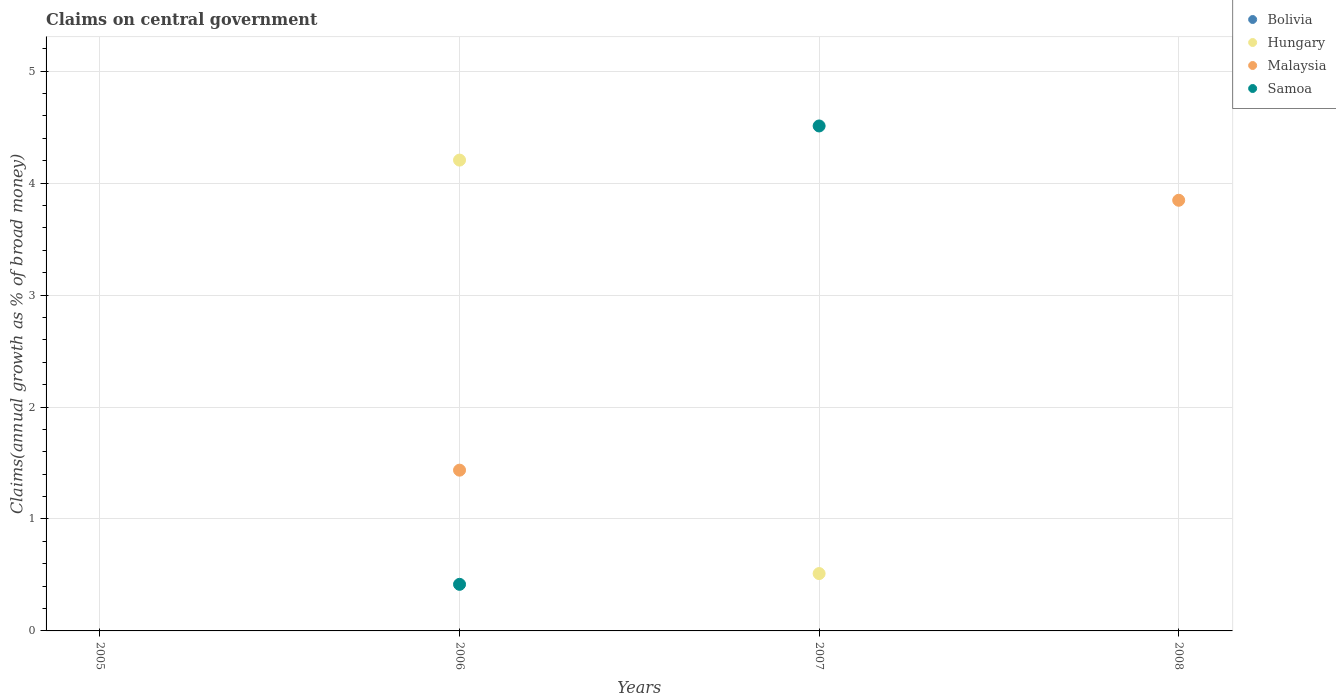What is the percentage of broad money claimed on centeral government in Samoa in 2008?
Your answer should be very brief. 0. Across all years, what is the maximum percentage of broad money claimed on centeral government in Hungary?
Offer a terse response. 4.21. In which year was the percentage of broad money claimed on centeral government in Samoa maximum?
Your response must be concise. 2007. What is the total percentage of broad money claimed on centeral government in Malaysia in the graph?
Give a very brief answer. 5.28. What is the difference between the percentage of broad money claimed on centeral government in Malaysia in 2006 and that in 2008?
Offer a very short reply. -2.41. What is the difference between the percentage of broad money claimed on centeral government in Samoa in 2008 and the percentage of broad money claimed on centeral government in Bolivia in 2007?
Give a very brief answer. 0. What is the average percentage of broad money claimed on centeral government in Malaysia per year?
Make the answer very short. 1.32. In the year 2007, what is the difference between the percentage of broad money claimed on centeral government in Hungary and percentage of broad money claimed on centeral government in Samoa?
Ensure brevity in your answer.  -4. What is the ratio of the percentage of broad money claimed on centeral government in Samoa in 2006 to that in 2007?
Offer a very short reply. 0.09. What is the difference between the highest and the lowest percentage of broad money claimed on centeral government in Hungary?
Your answer should be compact. 4.21. In how many years, is the percentage of broad money claimed on centeral government in Bolivia greater than the average percentage of broad money claimed on centeral government in Bolivia taken over all years?
Your answer should be very brief. 0. Is it the case that in every year, the sum of the percentage of broad money claimed on centeral government in Hungary and percentage of broad money claimed on centeral government in Bolivia  is greater than the sum of percentage of broad money claimed on centeral government in Malaysia and percentage of broad money claimed on centeral government in Samoa?
Your answer should be compact. No. Is the percentage of broad money claimed on centeral government in Samoa strictly less than the percentage of broad money claimed on centeral government in Malaysia over the years?
Provide a succinct answer. No. What is the difference between two consecutive major ticks on the Y-axis?
Ensure brevity in your answer.  1. Where does the legend appear in the graph?
Your answer should be compact. Top right. How many legend labels are there?
Your response must be concise. 4. How are the legend labels stacked?
Your answer should be compact. Vertical. What is the title of the graph?
Keep it short and to the point. Claims on central government. What is the label or title of the X-axis?
Offer a terse response. Years. What is the label or title of the Y-axis?
Offer a terse response. Claims(annual growth as % of broad money). What is the Claims(annual growth as % of broad money) of Bolivia in 2005?
Provide a short and direct response. 0. What is the Claims(annual growth as % of broad money) in Malaysia in 2005?
Provide a short and direct response. 0. What is the Claims(annual growth as % of broad money) in Samoa in 2005?
Your answer should be very brief. 0. What is the Claims(annual growth as % of broad money) in Hungary in 2006?
Give a very brief answer. 4.21. What is the Claims(annual growth as % of broad money) of Malaysia in 2006?
Your answer should be very brief. 1.44. What is the Claims(annual growth as % of broad money) of Samoa in 2006?
Ensure brevity in your answer.  0.42. What is the Claims(annual growth as % of broad money) in Hungary in 2007?
Give a very brief answer. 0.51. What is the Claims(annual growth as % of broad money) in Samoa in 2007?
Give a very brief answer. 4.51. What is the Claims(annual growth as % of broad money) of Bolivia in 2008?
Provide a short and direct response. 0. What is the Claims(annual growth as % of broad money) of Hungary in 2008?
Your answer should be compact. 0. What is the Claims(annual growth as % of broad money) of Malaysia in 2008?
Ensure brevity in your answer.  3.85. Across all years, what is the maximum Claims(annual growth as % of broad money) of Hungary?
Your answer should be compact. 4.21. Across all years, what is the maximum Claims(annual growth as % of broad money) of Malaysia?
Offer a terse response. 3.85. Across all years, what is the maximum Claims(annual growth as % of broad money) in Samoa?
Offer a very short reply. 4.51. Across all years, what is the minimum Claims(annual growth as % of broad money) of Samoa?
Offer a very short reply. 0. What is the total Claims(annual growth as % of broad money) of Hungary in the graph?
Give a very brief answer. 4.72. What is the total Claims(annual growth as % of broad money) of Malaysia in the graph?
Provide a short and direct response. 5.28. What is the total Claims(annual growth as % of broad money) in Samoa in the graph?
Offer a terse response. 4.93. What is the difference between the Claims(annual growth as % of broad money) of Hungary in 2006 and that in 2007?
Your answer should be compact. 3.69. What is the difference between the Claims(annual growth as % of broad money) in Samoa in 2006 and that in 2007?
Give a very brief answer. -4.09. What is the difference between the Claims(annual growth as % of broad money) in Malaysia in 2006 and that in 2008?
Ensure brevity in your answer.  -2.41. What is the difference between the Claims(annual growth as % of broad money) of Hungary in 2006 and the Claims(annual growth as % of broad money) of Samoa in 2007?
Your answer should be compact. -0.3. What is the difference between the Claims(annual growth as % of broad money) in Malaysia in 2006 and the Claims(annual growth as % of broad money) in Samoa in 2007?
Provide a succinct answer. -3.07. What is the difference between the Claims(annual growth as % of broad money) in Hungary in 2006 and the Claims(annual growth as % of broad money) in Malaysia in 2008?
Provide a succinct answer. 0.36. What is the difference between the Claims(annual growth as % of broad money) in Hungary in 2007 and the Claims(annual growth as % of broad money) in Malaysia in 2008?
Keep it short and to the point. -3.33. What is the average Claims(annual growth as % of broad money) of Bolivia per year?
Ensure brevity in your answer.  0. What is the average Claims(annual growth as % of broad money) of Hungary per year?
Your answer should be very brief. 1.18. What is the average Claims(annual growth as % of broad money) of Malaysia per year?
Your response must be concise. 1.32. What is the average Claims(annual growth as % of broad money) of Samoa per year?
Give a very brief answer. 1.23. In the year 2006, what is the difference between the Claims(annual growth as % of broad money) in Hungary and Claims(annual growth as % of broad money) in Malaysia?
Your answer should be compact. 2.77. In the year 2006, what is the difference between the Claims(annual growth as % of broad money) in Hungary and Claims(annual growth as % of broad money) in Samoa?
Keep it short and to the point. 3.79. In the year 2006, what is the difference between the Claims(annual growth as % of broad money) of Malaysia and Claims(annual growth as % of broad money) of Samoa?
Your answer should be compact. 1.02. In the year 2007, what is the difference between the Claims(annual growth as % of broad money) of Hungary and Claims(annual growth as % of broad money) of Samoa?
Give a very brief answer. -4. What is the ratio of the Claims(annual growth as % of broad money) of Hungary in 2006 to that in 2007?
Ensure brevity in your answer.  8.21. What is the ratio of the Claims(annual growth as % of broad money) of Samoa in 2006 to that in 2007?
Your answer should be very brief. 0.09. What is the ratio of the Claims(annual growth as % of broad money) of Malaysia in 2006 to that in 2008?
Your answer should be compact. 0.37. What is the difference between the highest and the lowest Claims(annual growth as % of broad money) of Hungary?
Your answer should be very brief. 4.21. What is the difference between the highest and the lowest Claims(annual growth as % of broad money) in Malaysia?
Your answer should be very brief. 3.85. What is the difference between the highest and the lowest Claims(annual growth as % of broad money) in Samoa?
Make the answer very short. 4.51. 